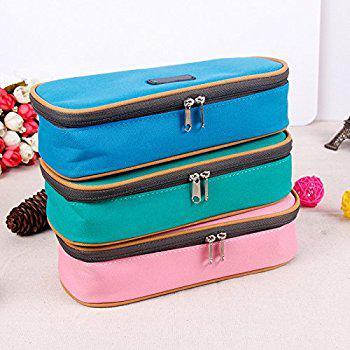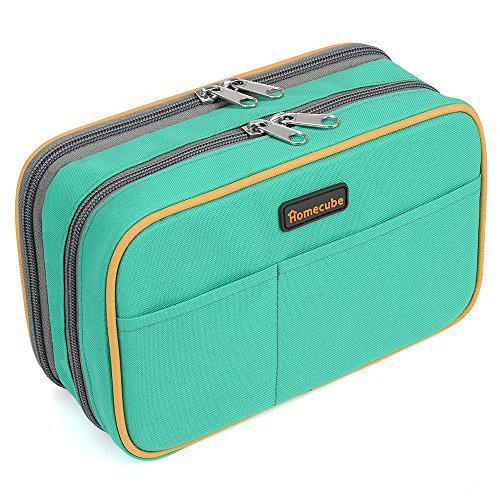The first image is the image on the left, the second image is the image on the right. Given the left and right images, does the statement "At leat one container is green." hold true? Answer yes or no. Yes. 